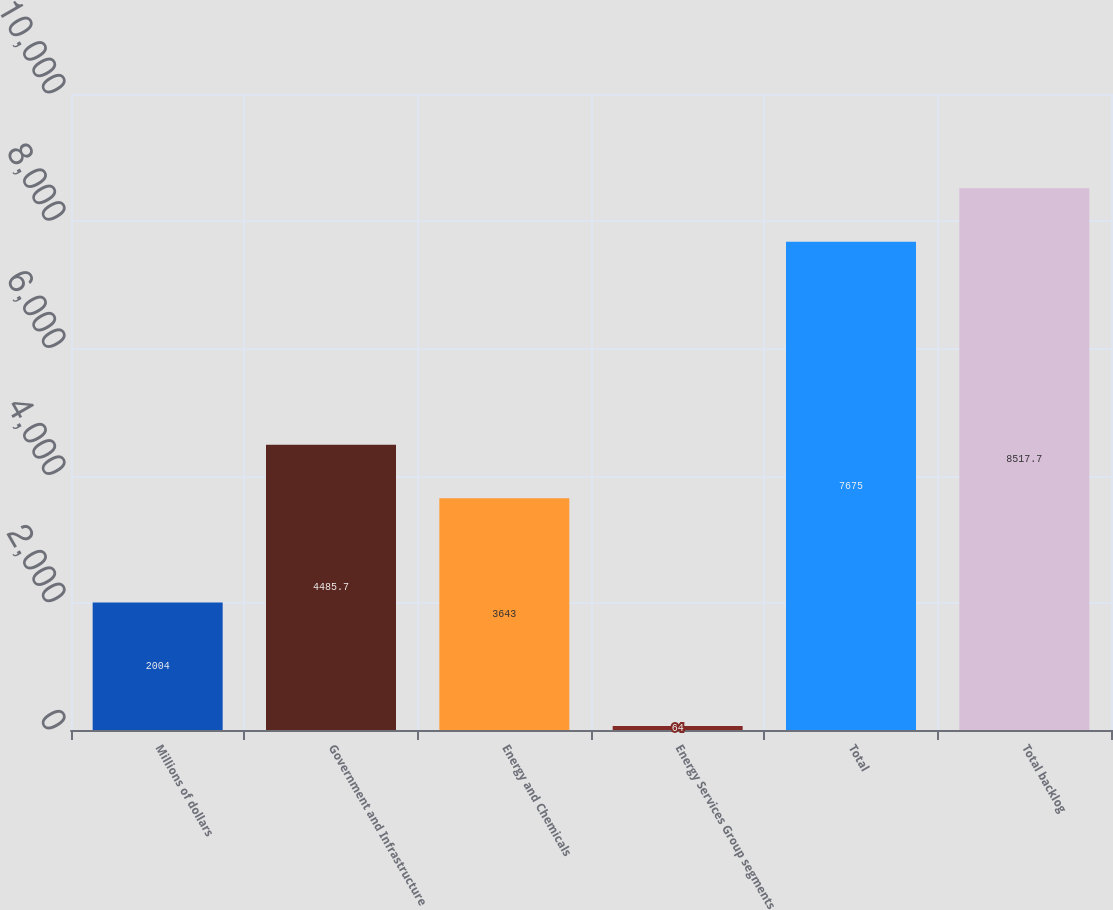<chart> <loc_0><loc_0><loc_500><loc_500><bar_chart><fcel>Millions of dollars<fcel>Government and Infrastructure<fcel>Energy and Chemicals<fcel>Energy Services Group segments<fcel>Total<fcel>Total backlog<nl><fcel>2004<fcel>4485.7<fcel>3643<fcel>64<fcel>7675<fcel>8517.7<nl></chart> 